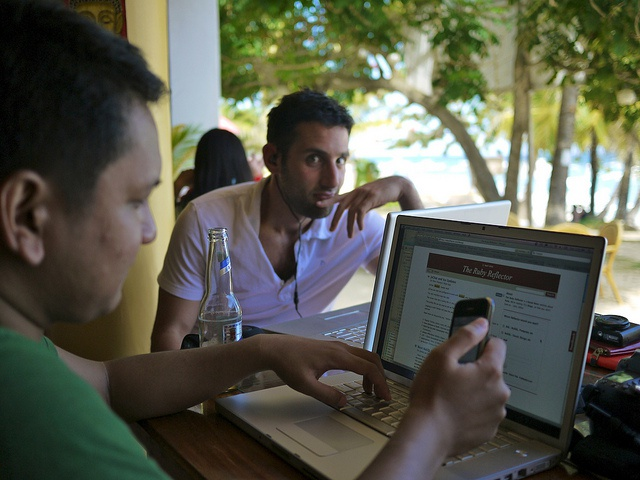Describe the objects in this image and their specific colors. I can see people in black, gray, and darkgreen tones, laptop in black, gray, and purple tones, people in black and gray tones, dining table in black, gray, and lightgray tones, and laptop in black, gray, lightgray, and lightblue tones in this image. 